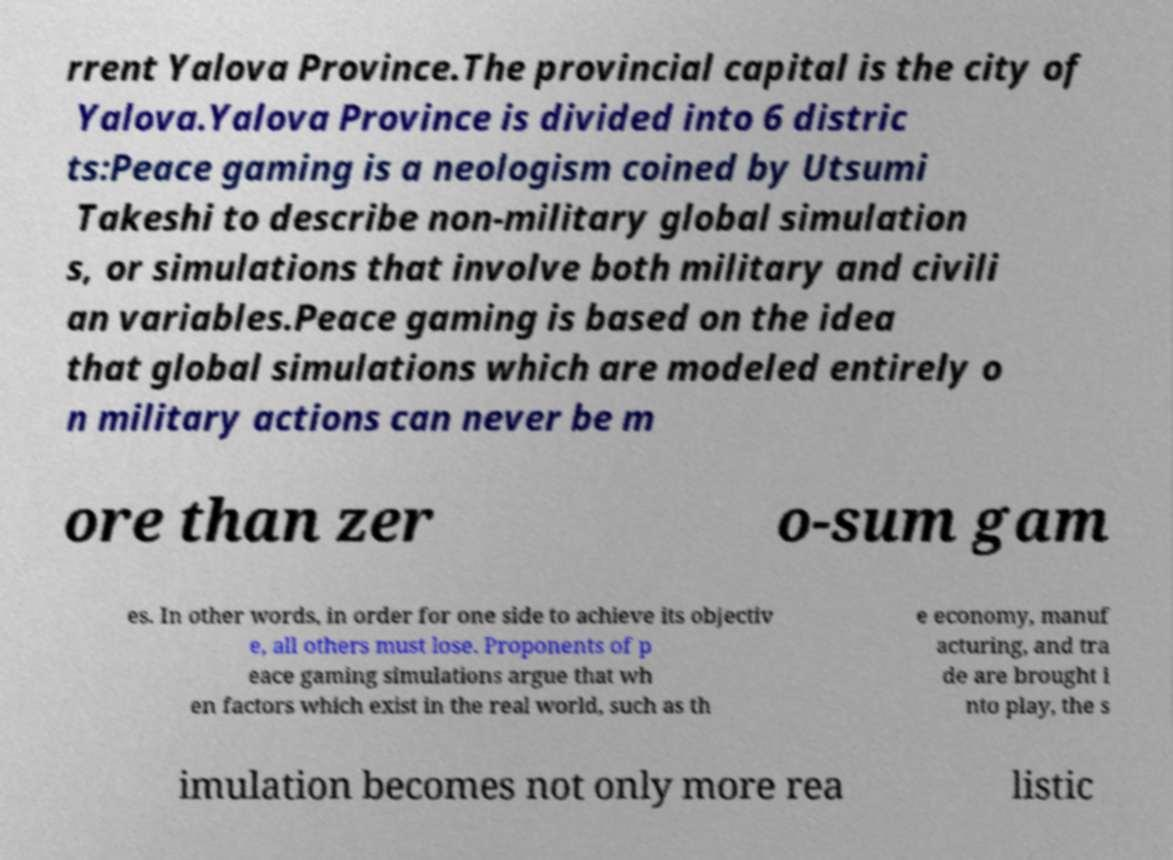There's text embedded in this image that I need extracted. Can you transcribe it verbatim? rrent Yalova Province.The provincial capital is the city of Yalova.Yalova Province is divided into 6 distric ts:Peace gaming is a neologism coined by Utsumi Takeshi to describe non-military global simulation s, or simulations that involve both military and civili an variables.Peace gaming is based on the idea that global simulations which are modeled entirely o n military actions can never be m ore than zer o-sum gam es. In other words, in order for one side to achieve its objectiv e, all others must lose. Proponents of p eace gaming simulations argue that wh en factors which exist in the real world, such as th e economy, manuf acturing, and tra de are brought i nto play, the s imulation becomes not only more rea listic 